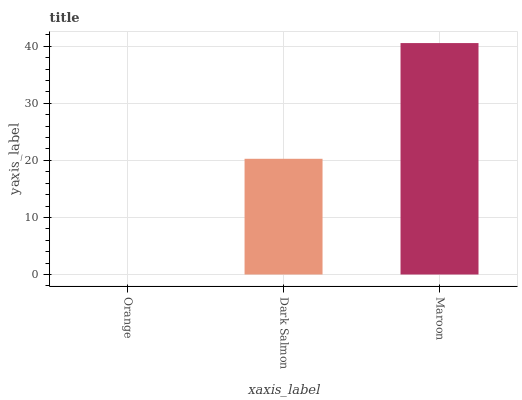Is Dark Salmon the minimum?
Answer yes or no. No. Is Dark Salmon the maximum?
Answer yes or no. No. Is Dark Salmon greater than Orange?
Answer yes or no. Yes. Is Orange less than Dark Salmon?
Answer yes or no. Yes. Is Orange greater than Dark Salmon?
Answer yes or no. No. Is Dark Salmon less than Orange?
Answer yes or no. No. Is Dark Salmon the high median?
Answer yes or no. Yes. Is Dark Salmon the low median?
Answer yes or no. Yes. Is Maroon the high median?
Answer yes or no. No. Is Orange the low median?
Answer yes or no. No. 